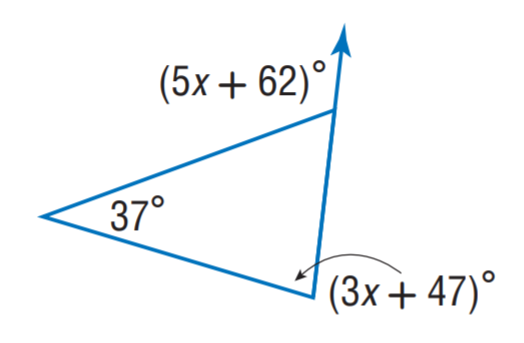Answer the mathemtical geometry problem and directly provide the correct option letter.
Question: Find x.
Choices: A: 9 B: 11 C: 37 D: 47 B 